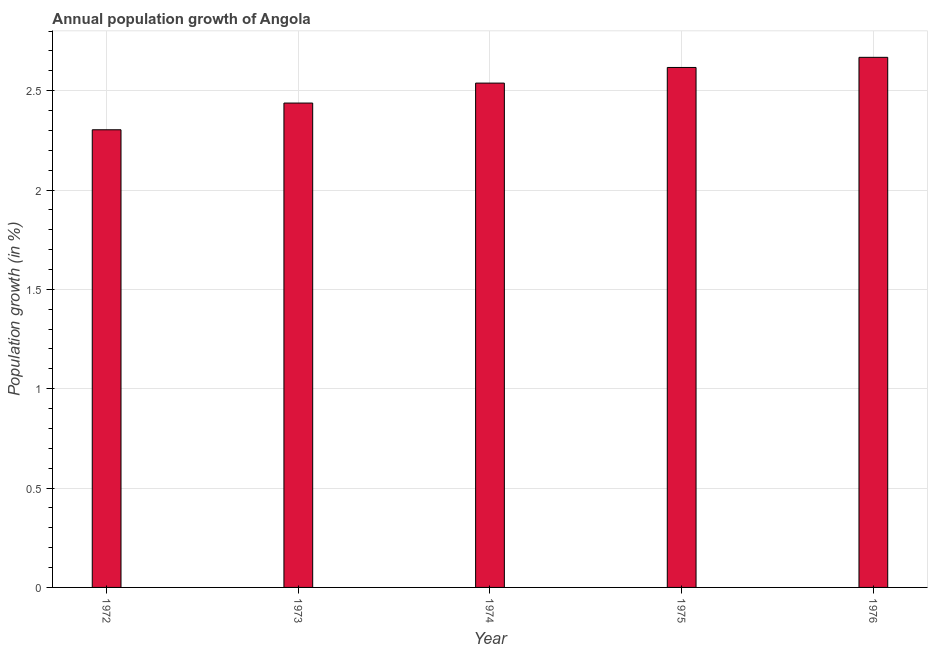Does the graph contain any zero values?
Offer a very short reply. No. Does the graph contain grids?
Your answer should be compact. Yes. What is the title of the graph?
Give a very brief answer. Annual population growth of Angola. What is the label or title of the Y-axis?
Make the answer very short. Population growth (in %). What is the population growth in 1976?
Keep it short and to the point. 2.67. Across all years, what is the maximum population growth?
Provide a short and direct response. 2.67. Across all years, what is the minimum population growth?
Offer a very short reply. 2.3. In which year was the population growth maximum?
Your answer should be compact. 1976. In which year was the population growth minimum?
Your answer should be very brief. 1972. What is the sum of the population growth?
Provide a short and direct response. 12.56. What is the difference between the population growth in 1975 and 1976?
Offer a terse response. -0.05. What is the average population growth per year?
Provide a succinct answer. 2.51. What is the median population growth?
Provide a short and direct response. 2.54. In how many years, is the population growth greater than 0.9 %?
Offer a very short reply. 5. What is the ratio of the population growth in 1972 to that in 1976?
Ensure brevity in your answer.  0.86. Is the population growth in 1975 less than that in 1976?
Your answer should be very brief. Yes. What is the difference between the highest and the second highest population growth?
Keep it short and to the point. 0.05. What is the difference between the highest and the lowest population growth?
Your response must be concise. 0.36. In how many years, is the population growth greater than the average population growth taken over all years?
Make the answer very short. 3. How many bars are there?
Your answer should be very brief. 5. Are all the bars in the graph horizontal?
Keep it short and to the point. No. What is the difference between two consecutive major ticks on the Y-axis?
Make the answer very short. 0.5. Are the values on the major ticks of Y-axis written in scientific E-notation?
Make the answer very short. No. What is the Population growth (in %) in 1972?
Offer a very short reply. 2.3. What is the Population growth (in %) of 1973?
Give a very brief answer. 2.44. What is the Population growth (in %) of 1974?
Your answer should be compact. 2.54. What is the Population growth (in %) in 1975?
Offer a terse response. 2.62. What is the Population growth (in %) in 1976?
Your response must be concise. 2.67. What is the difference between the Population growth (in %) in 1972 and 1973?
Offer a terse response. -0.13. What is the difference between the Population growth (in %) in 1972 and 1974?
Offer a very short reply. -0.23. What is the difference between the Population growth (in %) in 1972 and 1975?
Provide a short and direct response. -0.31. What is the difference between the Population growth (in %) in 1972 and 1976?
Your response must be concise. -0.36. What is the difference between the Population growth (in %) in 1973 and 1974?
Give a very brief answer. -0.1. What is the difference between the Population growth (in %) in 1973 and 1975?
Offer a very short reply. -0.18. What is the difference between the Population growth (in %) in 1973 and 1976?
Offer a terse response. -0.23. What is the difference between the Population growth (in %) in 1974 and 1975?
Give a very brief answer. -0.08. What is the difference between the Population growth (in %) in 1974 and 1976?
Give a very brief answer. -0.13. What is the difference between the Population growth (in %) in 1975 and 1976?
Make the answer very short. -0.05. What is the ratio of the Population growth (in %) in 1972 to that in 1973?
Ensure brevity in your answer.  0.94. What is the ratio of the Population growth (in %) in 1972 to that in 1974?
Offer a very short reply. 0.91. What is the ratio of the Population growth (in %) in 1972 to that in 1976?
Your answer should be compact. 0.86. What is the ratio of the Population growth (in %) in 1973 to that in 1975?
Your answer should be very brief. 0.93. What is the ratio of the Population growth (in %) in 1973 to that in 1976?
Offer a terse response. 0.91. What is the ratio of the Population growth (in %) in 1974 to that in 1976?
Offer a terse response. 0.95. 